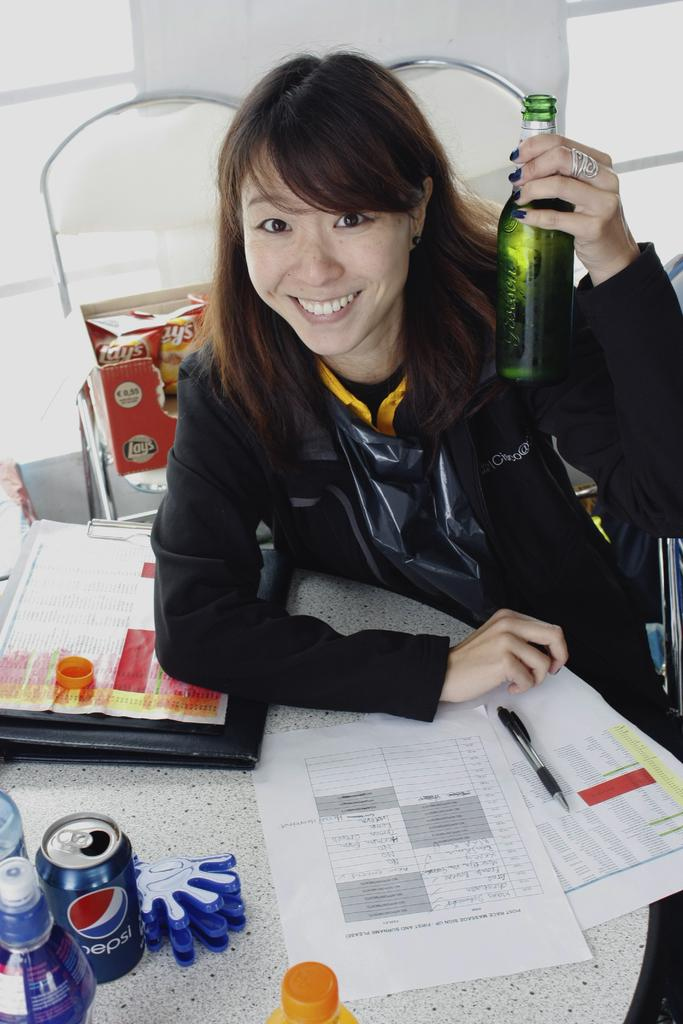Who is present in the image? There is a woman in the image. What is the woman doing in the image? The woman is sitting in the image. What is the woman holding in the image? The woman is holding a bottle in the image. What is the woman's facial expression in the image? The woman is smiling in the image. What objects are in front of the woman in the image? There are papers, cans, and bottles in front of the woman in the image. What type of texture can be seen on the secretary's desk in the image? There is no secretary present in the image, and therefore no desk or texture associated with it. 